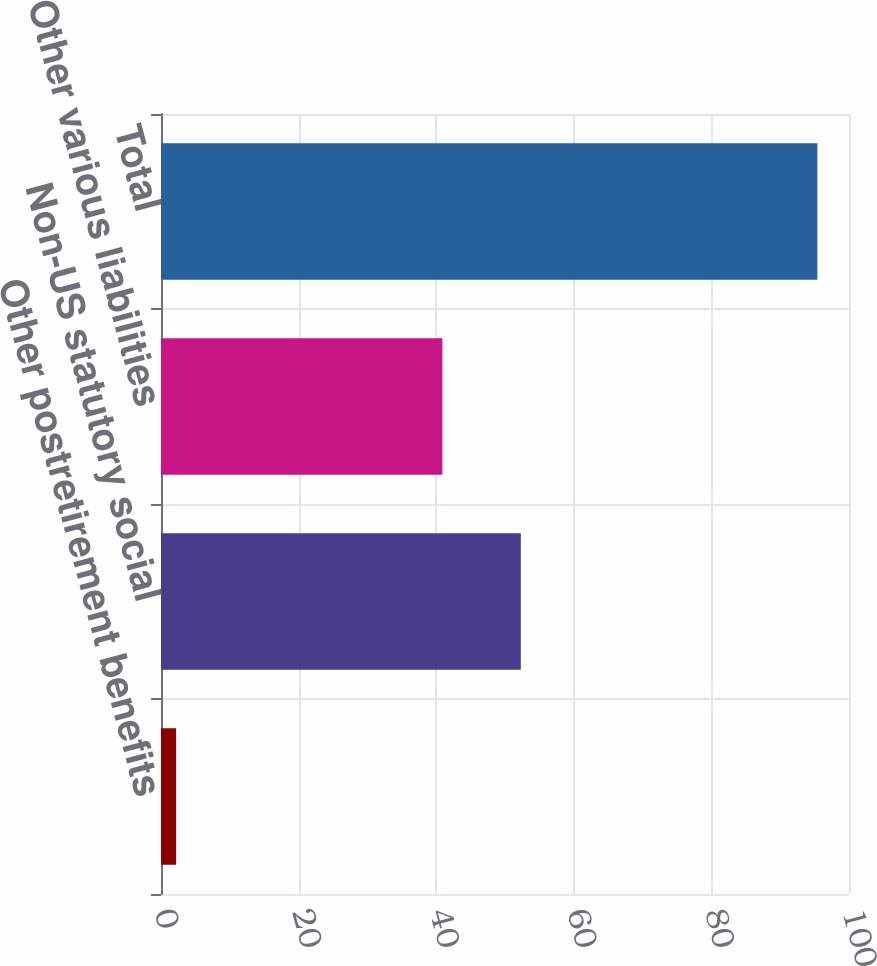Convert chart to OTSL. <chart><loc_0><loc_0><loc_500><loc_500><bar_chart><fcel>Other postretirement benefits<fcel>Non-US statutory social<fcel>Other various liabilities<fcel>Total<nl><fcel>2.2<fcel>52.3<fcel>40.9<fcel>95.4<nl></chart> 